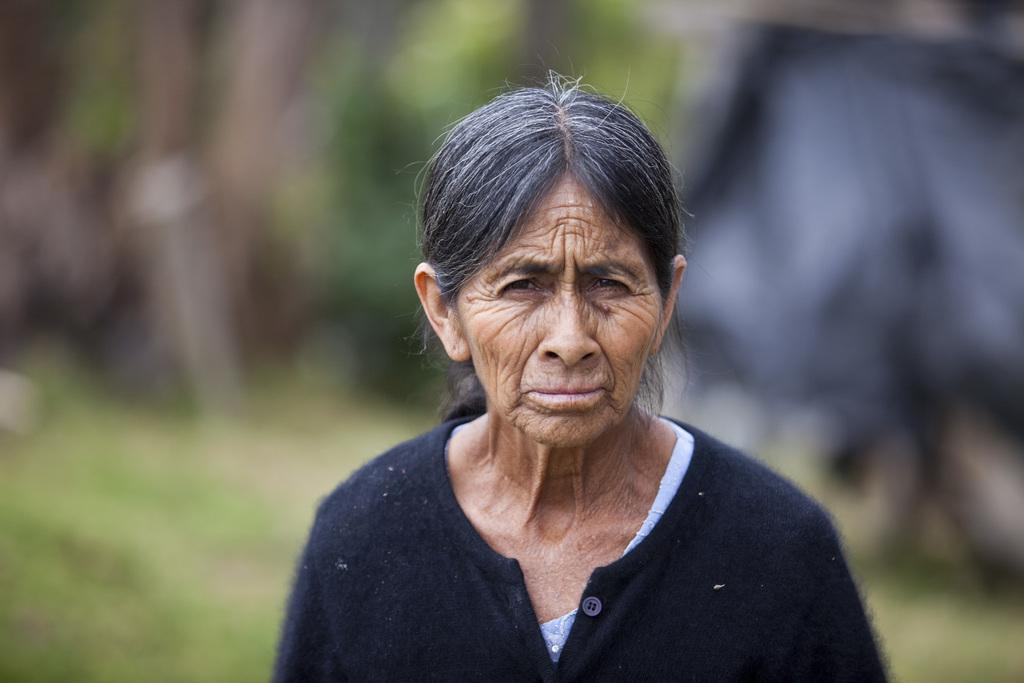Who is the main subject in the image? There is a woman in the image. What is the woman wearing? The woman is wearing a jacket. Can you describe the background of the image? The background of the image is blurry. How many geese can be seen in the image? There are no geese present in the image. What type of cable is connected to the woman's jacket in the image? There is no cable connected to the woman's jacket in the image. 